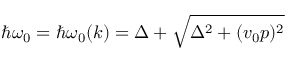Convert formula to latex. <formula><loc_0><loc_0><loc_500><loc_500>\hbar { \omega } _ { 0 } = \hbar { \omega } _ { 0 } ( k ) = \Delta + \sqrt { \Delta ^ { 2 } + ( v _ { 0 } p ) ^ { 2 } }</formula> 